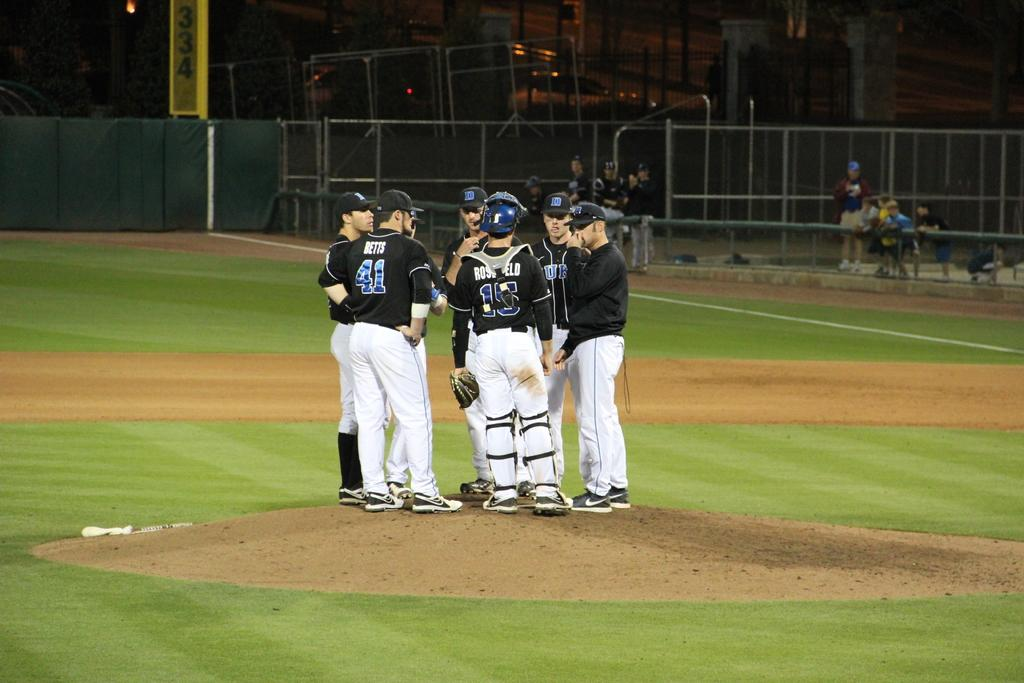<image>
Create a compact narrative representing the image presented. A number of Duke baseball players, including number 41 Betts meet on the mound. 